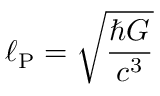<formula> <loc_0><loc_0><loc_500><loc_500>\ell _ { P } = { \sqrt { \frac { \hbar { G } } { c ^ { 3 } } } }</formula> 